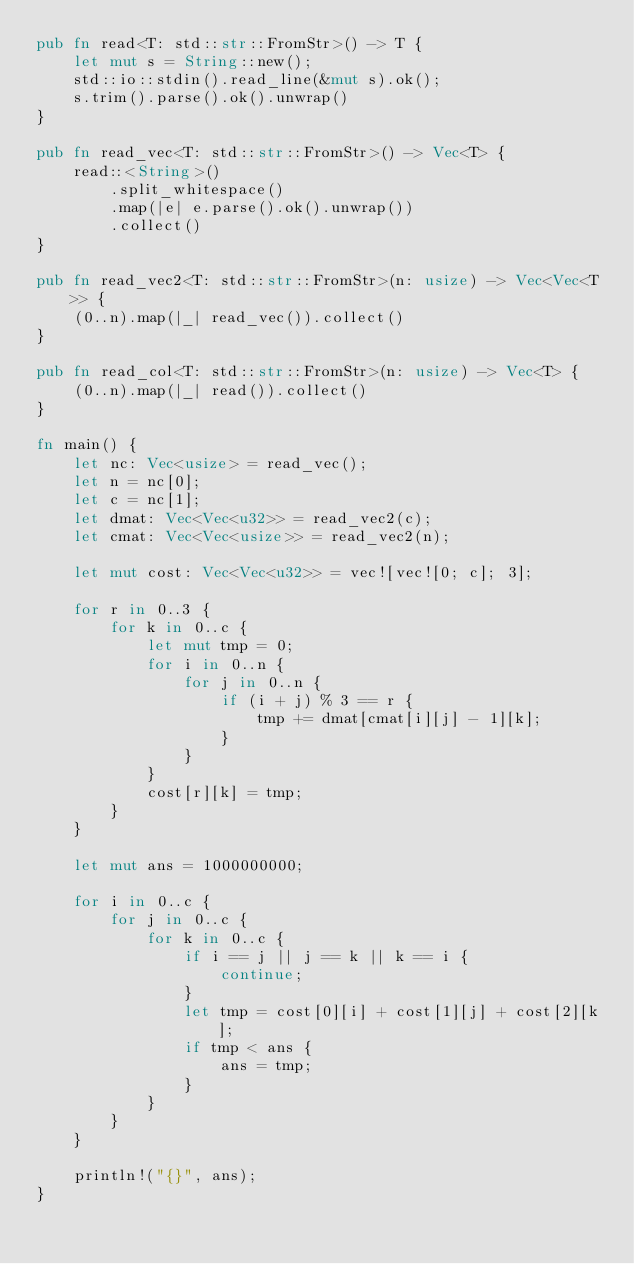Convert code to text. <code><loc_0><loc_0><loc_500><loc_500><_Rust_>pub fn read<T: std::str::FromStr>() -> T {
    let mut s = String::new();
    std::io::stdin().read_line(&mut s).ok();
    s.trim().parse().ok().unwrap()
}

pub fn read_vec<T: std::str::FromStr>() -> Vec<T> {
    read::<String>()
        .split_whitespace()
        .map(|e| e.parse().ok().unwrap())
        .collect()
}

pub fn read_vec2<T: std::str::FromStr>(n: usize) -> Vec<Vec<T>> {
    (0..n).map(|_| read_vec()).collect()
}

pub fn read_col<T: std::str::FromStr>(n: usize) -> Vec<T> {
    (0..n).map(|_| read()).collect()
}

fn main() {
    let nc: Vec<usize> = read_vec();
    let n = nc[0];
    let c = nc[1];
    let dmat: Vec<Vec<u32>> = read_vec2(c);
    let cmat: Vec<Vec<usize>> = read_vec2(n);

    let mut cost: Vec<Vec<u32>> = vec![vec![0; c]; 3];

    for r in 0..3 {
        for k in 0..c {
            let mut tmp = 0;
            for i in 0..n {
                for j in 0..n {
                    if (i + j) % 3 == r {
                        tmp += dmat[cmat[i][j] - 1][k];
                    }
                }
            }
            cost[r][k] = tmp;
        }
    }

    let mut ans = 1000000000;

    for i in 0..c {
        for j in 0..c {
            for k in 0..c {
                if i == j || j == k || k == i {
                    continue;
                }
                let tmp = cost[0][i] + cost[1][j] + cost[2][k];
                if tmp < ans {
                    ans = tmp;
                }
            }
        }
    }

    println!("{}", ans);
}
</code> 